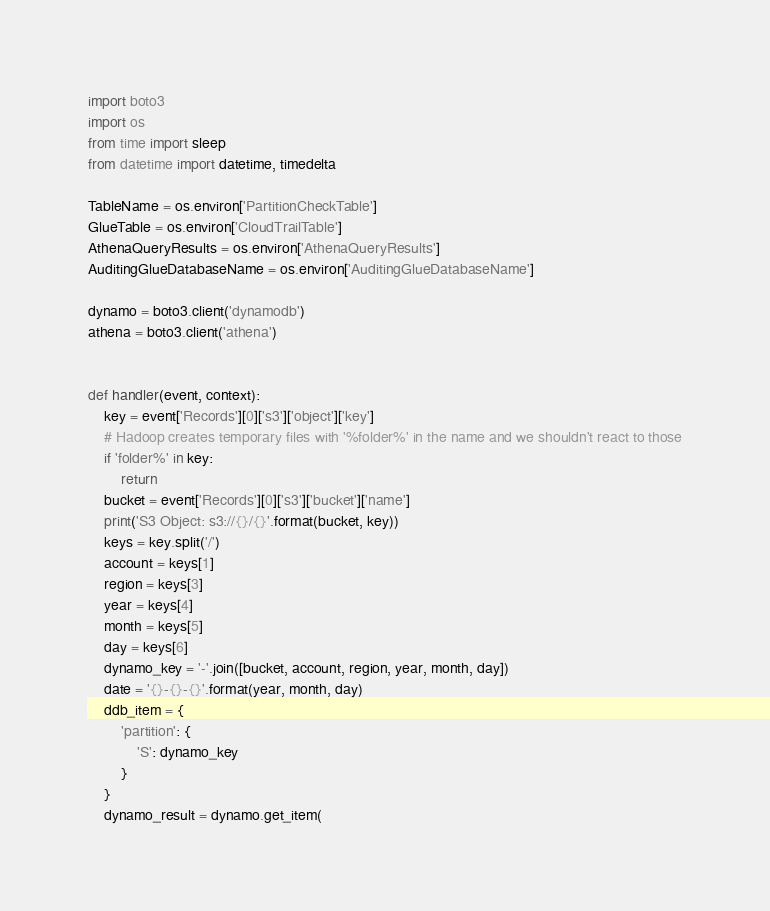<code> <loc_0><loc_0><loc_500><loc_500><_Python_>import boto3
import os
from time import sleep
from datetime import datetime, timedelta

TableName = os.environ['PartitionCheckTable']
GlueTable = os.environ['CloudTrailTable']
AthenaQueryResults = os.environ['AthenaQueryResults']
AuditingGlueDatabaseName = os.environ['AuditingGlueDatabaseName']

dynamo = boto3.client('dynamodb')
athena = boto3.client('athena')


def handler(event, context):
    key = event['Records'][0]['s3']['object']['key']
    # Hadoop creates temporary files with '%folder%' in the name and we shouldn't react to those
    if 'folder%' in key:
        return
    bucket = event['Records'][0]['s3']['bucket']['name']
    print('S3 Object: s3://{}/{}'.format(bucket, key))
    keys = key.split('/')
    account = keys[1]
    region = keys[3]
    year = keys[4]
    month = keys[5]
    day = keys[6]
    dynamo_key = '-'.join([bucket, account, region, year, month, day])
    date = '{}-{}-{}'.format(year, month, day)
    ddb_item = {
        'partition': {
            'S': dynamo_key
        }
    }
    dynamo_result = dynamo.get_item(</code> 